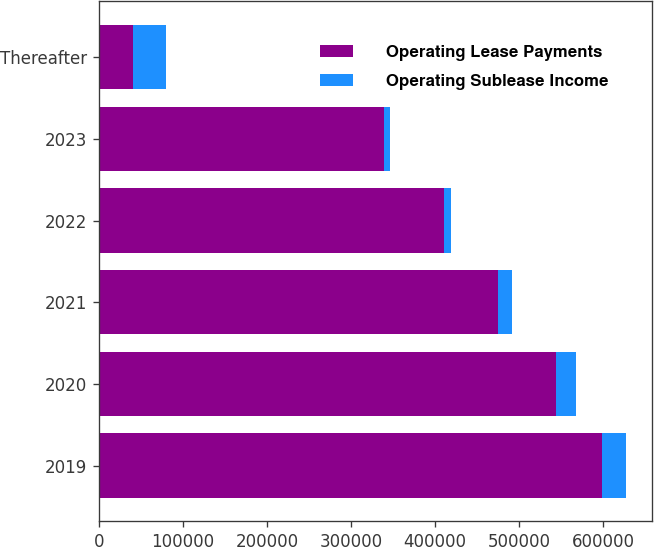Convert chart to OTSL. <chart><loc_0><loc_0><loc_500><loc_500><stacked_bar_chart><ecel><fcel>2019<fcel>2020<fcel>2021<fcel>2022<fcel>2023<fcel>Thereafter<nl><fcel>Operating Lease Payments<fcel>598483<fcel>543125<fcel>474478<fcel>411002<fcel>338630<fcel>40286<nl><fcel>Operating Sublease Income<fcel>28083<fcel>24115<fcel>17221<fcel>7932<fcel>7661<fcel>40286<nl></chart> 